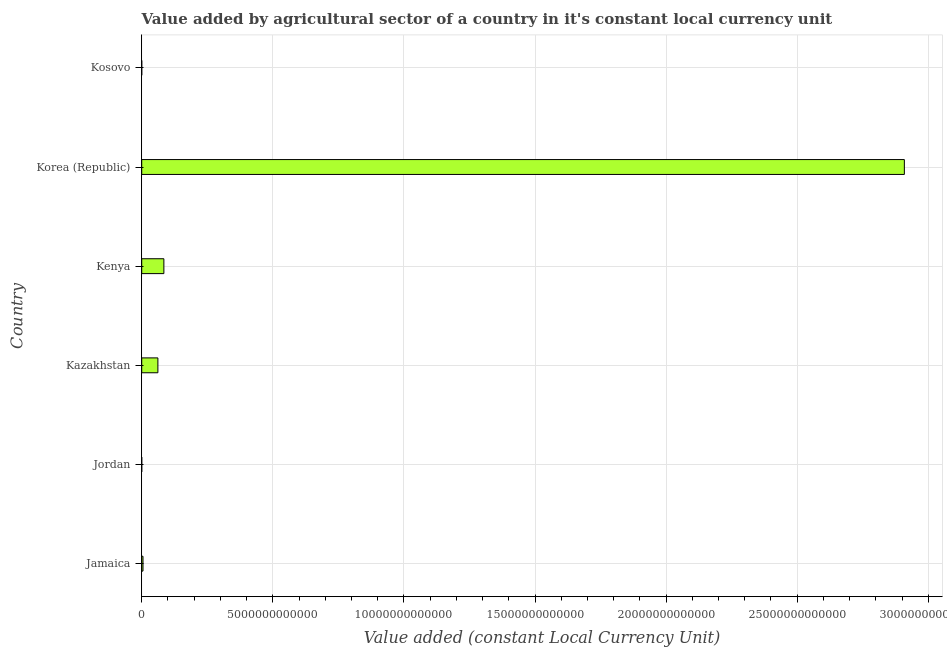Does the graph contain grids?
Offer a terse response. Yes. What is the title of the graph?
Provide a short and direct response. Value added by agricultural sector of a country in it's constant local currency unit. What is the label or title of the X-axis?
Make the answer very short. Value added (constant Local Currency Unit). What is the value added by agriculture sector in Jamaica?
Keep it short and to the point. 4.88e+1. Across all countries, what is the maximum value added by agriculture sector?
Give a very brief answer. 2.91e+13. Across all countries, what is the minimum value added by agriculture sector?
Give a very brief answer. 3.63e+08. In which country was the value added by agriculture sector minimum?
Provide a short and direct response. Jordan. What is the sum of the value added by agriculture sector?
Your answer should be compact. 3.06e+13. What is the difference between the value added by agriculture sector in Jordan and Kosovo?
Your answer should be very brief. -2.06e+08. What is the average value added by agriculture sector per country?
Ensure brevity in your answer.  5.10e+12. What is the median value added by agriculture sector?
Give a very brief answer. 3.33e+11. In how many countries, is the value added by agriculture sector greater than 25000000000000 LCU?
Keep it short and to the point. 1. Is the value added by agriculture sector in Jordan less than that in Korea (Republic)?
Your response must be concise. Yes. Is the difference between the value added by agriculture sector in Kazakhstan and Kosovo greater than the difference between any two countries?
Your response must be concise. No. What is the difference between the highest and the second highest value added by agriculture sector?
Offer a very short reply. 2.82e+13. What is the difference between the highest and the lowest value added by agriculture sector?
Your answer should be very brief. 2.91e+13. In how many countries, is the value added by agriculture sector greater than the average value added by agriculture sector taken over all countries?
Your response must be concise. 1. How many bars are there?
Make the answer very short. 6. What is the difference between two consecutive major ticks on the X-axis?
Provide a succinct answer. 5.00e+12. Are the values on the major ticks of X-axis written in scientific E-notation?
Give a very brief answer. No. What is the Value added (constant Local Currency Unit) in Jamaica?
Your response must be concise. 4.88e+1. What is the Value added (constant Local Currency Unit) in Jordan?
Your answer should be very brief. 3.63e+08. What is the Value added (constant Local Currency Unit) of Kazakhstan?
Provide a succinct answer. 6.17e+11. What is the Value added (constant Local Currency Unit) of Kenya?
Provide a succinct answer. 8.45e+11. What is the Value added (constant Local Currency Unit) of Korea (Republic)?
Keep it short and to the point. 2.91e+13. What is the Value added (constant Local Currency Unit) of Kosovo?
Offer a very short reply. 5.69e+08. What is the difference between the Value added (constant Local Currency Unit) in Jamaica and Jordan?
Make the answer very short. 4.85e+1. What is the difference between the Value added (constant Local Currency Unit) in Jamaica and Kazakhstan?
Offer a terse response. -5.68e+11. What is the difference between the Value added (constant Local Currency Unit) in Jamaica and Kenya?
Provide a succinct answer. -7.96e+11. What is the difference between the Value added (constant Local Currency Unit) in Jamaica and Korea (Republic)?
Provide a short and direct response. -2.90e+13. What is the difference between the Value added (constant Local Currency Unit) in Jamaica and Kosovo?
Your answer should be very brief. 4.83e+1. What is the difference between the Value added (constant Local Currency Unit) in Jordan and Kazakhstan?
Your answer should be very brief. -6.16e+11. What is the difference between the Value added (constant Local Currency Unit) in Jordan and Kenya?
Keep it short and to the point. -8.44e+11. What is the difference between the Value added (constant Local Currency Unit) in Jordan and Korea (Republic)?
Offer a very short reply. -2.91e+13. What is the difference between the Value added (constant Local Currency Unit) in Jordan and Kosovo?
Keep it short and to the point. -2.06e+08. What is the difference between the Value added (constant Local Currency Unit) in Kazakhstan and Kenya?
Ensure brevity in your answer.  -2.28e+11. What is the difference between the Value added (constant Local Currency Unit) in Kazakhstan and Korea (Republic)?
Make the answer very short. -2.85e+13. What is the difference between the Value added (constant Local Currency Unit) in Kazakhstan and Kosovo?
Make the answer very short. 6.16e+11. What is the difference between the Value added (constant Local Currency Unit) in Kenya and Korea (Republic)?
Your answer should be compact. -2.82e+13. What is the difference between the Value added (constant Local Currency Unit) in Kenya and Kosovo?
Offer a very short reply. 8.44e+11. What is the difference between the Value added (constant Local Currency Unit) in Korea (Republic) and Kosovo?
Offer a terse response. 2.91e+13. What is the ratio of the Value added (constant Local Currency Unit) in Jamaica to that in Jordan?
Provide a short and direct response. 134.53. What is the ratio of the Value added (constant Local Currency Unit) in Jamaica to that in Kazakhstan?
Give a very brief answer. 0.08. What is the ratio of the Value added (constant Local Currency Unit) in Jamaica to that in Kenya?
Provide a short and direct response. 0.06. What is the ratio of the Value added (constant Local Currency Unit) in Jamaica to that in Korea (Republic)?
Your answer should be compact. 0. What is the ratio of the Value added (constant Local Currency Unit) in Jamaica to that in Kosovo?
Make the answer very short. 85.87. What is the ratio of the Value added (constant Local Currency Unit) in Jordan to that in Kazakhstan?
Keep it short and to the point. 0. What is the ratio of the Value added (constant Local Currency Unit) in Jordan to that in Kosovo?
Make the answer very short. 0.64. What is the ratio of the Value added (constant Local Currency Unit) in Kazakhstan to that in Kenya?
Offer a terse response. 0.73. What is the ratio of the Value added (constant Local Currency Unit) in Kazakhstan to that in Korea (Republic)?
Offer a terse response. 0.02. What is the ratio of the Value added (constant Local Currency Unit) in Kazakhstan to that in Kosovo?
Provide a short and direct response. 1084.42. What is the ratio of the Value added (constant Local Currency Unit) in Kenya to that in Korea (Republic)?
Provide a short and direct response. 0.03. What is the ratio of the Value added (constant Local Currency Unit) in Kenya to that in Kosovo?
Offer a terse response. 1485.61. What is the ratio of the Value added (constant Local Currency Unit) in Korea (Republic) to that in Kosovo?
Provide a succinct answer. 5.12e+04. 